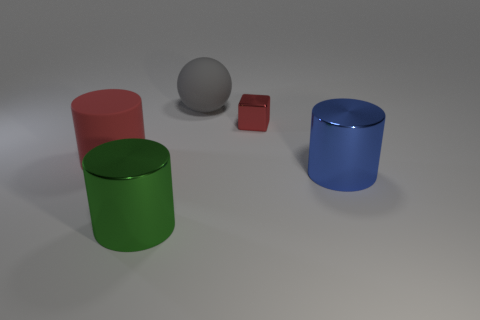Can you tell me the colors of the objects in the image? Certainly, there are four distinct objects in the image, each with its own color. Starting from the left, there's a green cylinder, followed by a red cylinder. On the right side, we have a blue cylinder. Finally, in between the red and blue cylinders, there's a small cube that is also red, and behind it, a gray sphere. 